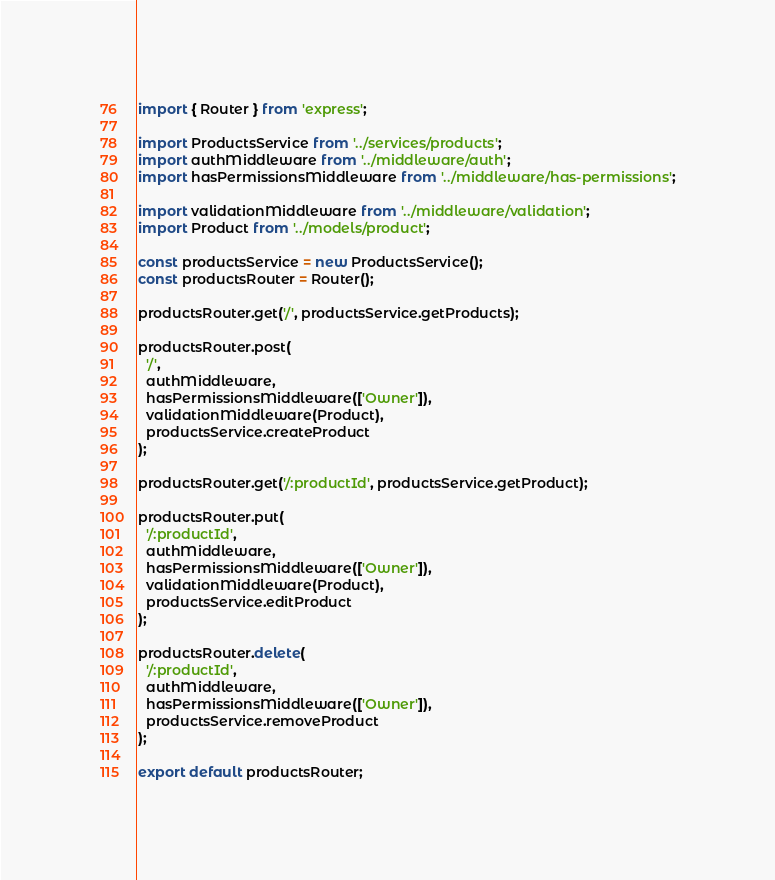Convert code to text. <code><loc_0><loc_0><loc_500><loc_500><_TypeScript_>import { Router } from 'express';

import ProductsService from '../services/products';
import authMiddleware from '../middleware/auth';
import hasPermissionsMiddleware from '../middleware/has-permissions';

import validationMiddleware from '../middleware/validation';
import Product from '../models/product';

const productsService = new ProductsService();
const productsRouter = Router();

productsRouter.get('/', productsService.getProducts);

productsRouter.post(
  '/',
  authMiddleware,
  hasPermissionsMiddleware(['Owner']),
  validationMiddleware(Product),
  productsService.createProduct
);

productsRouter.get('/:productId', productsService.getProduct);

productsRouter.put(
  '/:productId',
  authMiddleware,
  hasPermissionsMiddleware(['Owner']),
  validationMiddleware(Product),
  productsService.editProduct
);

productsRouter.delete(
  '/:productId',
  authMiddleware,
  hasPermissionsMiddleware(['Owner']),
  productsService.removeProduct
);

export default productsRouter;
</code> 